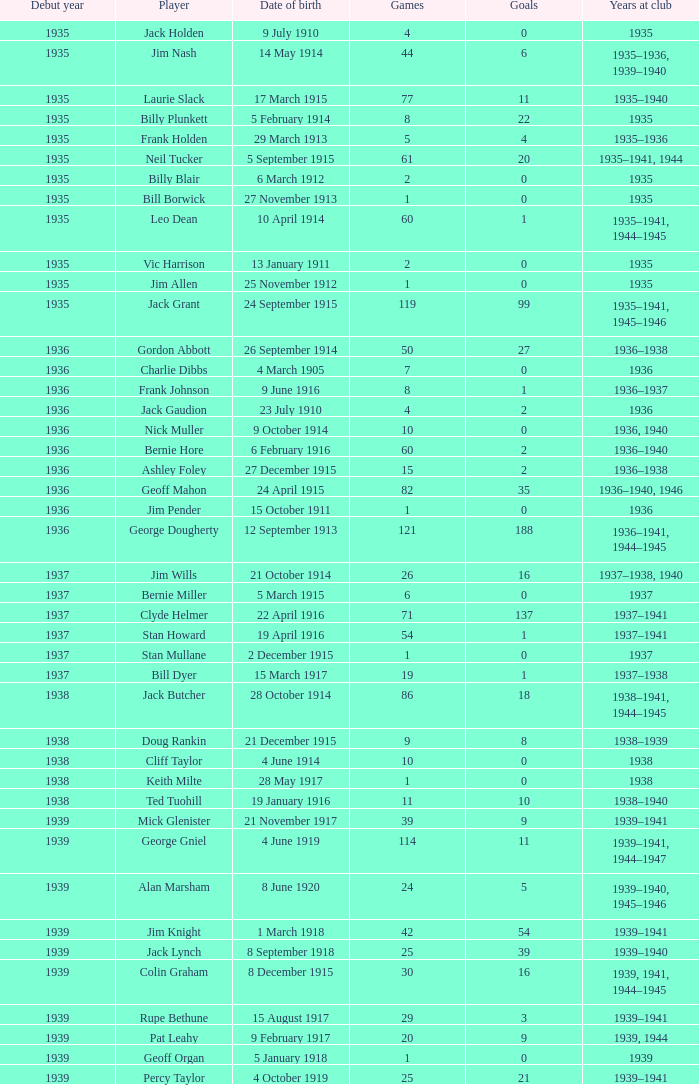Help me parse the entirety of this table. {'header': ['Debut year', 'Player', 'Date of birth', 'Games', 'Goals', 'Years at club'], 'rows': [['1935', 'Jack Holden', '9 July 1910', '4', '0', '1935'], ['1935', 'Jim Nash', '14 May 1914', '44', '6', '1935–1936, 1939–1940'], ['1935', 'Laurie Slack', '17 March 1915', '77', '11', '1935–1940'], ['1935', 'Billy Plunkett', '5 February 1914', '8', '22', '1935'], ['1935', 'Frank Holden', '29 March 1913', '5', '4', '1935–1936'], ['1935', 'Neil Tucker', '5 September 1915', '61', '20', '1935–1941, 1944'], ['1935', 'Billy Blair', '6 March 1912', '2', '0', '1935'], ['1935', 'Bill Borwick', '27 November 1913', '1', '0', '1935'], ['1935', 'Leo Dean', '10 April 1914', '60', '1', '1935–1941, 1944–1945'], ['1935', 'Vic Harrison', '13 January 1911', '2', '0', '1935'], ['1935', 'Jim Allen', '25 November 1912', '1', '0', '1935'], ['1935', 'Jack Grant', '24 September 1915', '119', '99', '1935–1941, 1945–1946'], ['1936', 'Gordon Abbott', '26 September 1914', '50', '27', '1936–1938'], ['1936', 'Charlie Dibbs', '4 March 1905', '7', '0', '1936'], ['1936', 'Frank Johnson', '9 June 1916', '8', '1', '1936–1937'], ['1936', 'Jack Gaudion', '23 July 1910', '4', '2', '1936'], ['1936', 'Nick Muller', '9 October 1914', '10', '0', '1936, 1940'], ['1936', 'Bernie Hore', '6 February 1916', '60', '2', '1936–1940'], ['1936', 'Ashley Foley', '27 December 1915', '15', '2', '1936–1938'], ['1936', 'Geoff Mahon', '24 April 1915', '82', '35', '1936–1940, 1946'], ['1936', 'Jim Pender', '15 October 1911', '1', '0', '1936'], ['1936', 'George Dougherty', '12 September 1913', '121', '188', '1936–1941, 1944–1945'], ['1937', 'Jim Wills', '21 October 1914', '26', '16', '1937–1938, 1940'], ['1937', 'Bernie Miller', '5 March 1915', '6', '0', '1937'], ['1937', 'Clyde Helmer', '22 April 1916', '71', '137', '1937–1941'], ['1937', 'Stan Howard', '19 April 1916', '54', '1', '1937–1941'], ['1937', 'Stan Mullane', '2 December 1915', '1', '0', '1937'], ['1937', 'Bill Dyer', '15 March 1917', '19', '1', '1937–1938'], ['1938', 'Jack Butcher', '28 October 1914', '86', '18', '1938–1941, 1944–1945'], ['1938', 'Doug Rankin', '21 December 1915', '9', '8', '1938–1939'], ['1938', 'Cliff Taylor', '4 June 1914', '10', '0', '1938'], ['1938', 'Keith Milte', '28 May 1917', '1', '0', '1938'], ['1938', 'Ted Tuohill', '19 January 1916', '11', '10', '1938–1940'], ['1939', 'Mick Glenister', '21 November 1917', '39', '9', '1939–1941'], ['1939', 'George Gniel', '4 June 1919', '114', '11', '1939–1941, 1944–1947'], ['1939', 'Alan Marsham', '8 June 1920', '24', '5', '1939–1940, 1945–1946'], ['1939', 'Jim Knight', '1 March 1918', '42', '54', '1939–1941'], ['1939', 'Jack Lynch', '8 September 1918', '25', '39', '1939–1940'], ['1939', 'Colin Graham', '8 December 1915', '30', '16', '1939, 1941, 1944–1945'], ['1939', 'Rupe Bethune', '15 August 1917', '29', '3', '1939–1941'], ['1939', 'Pat Leahy', '9 February 1917', '20', '9', '1939, 1944'], ['1939', 'Geoff Organ', '5 January 1918', '1', '0', '1939'], ['1939', 'Percy Taylor', '4 October 1919', '25', '21', '1939–1941']]} Prior to 1935, how many games featured 22 goals? None. 